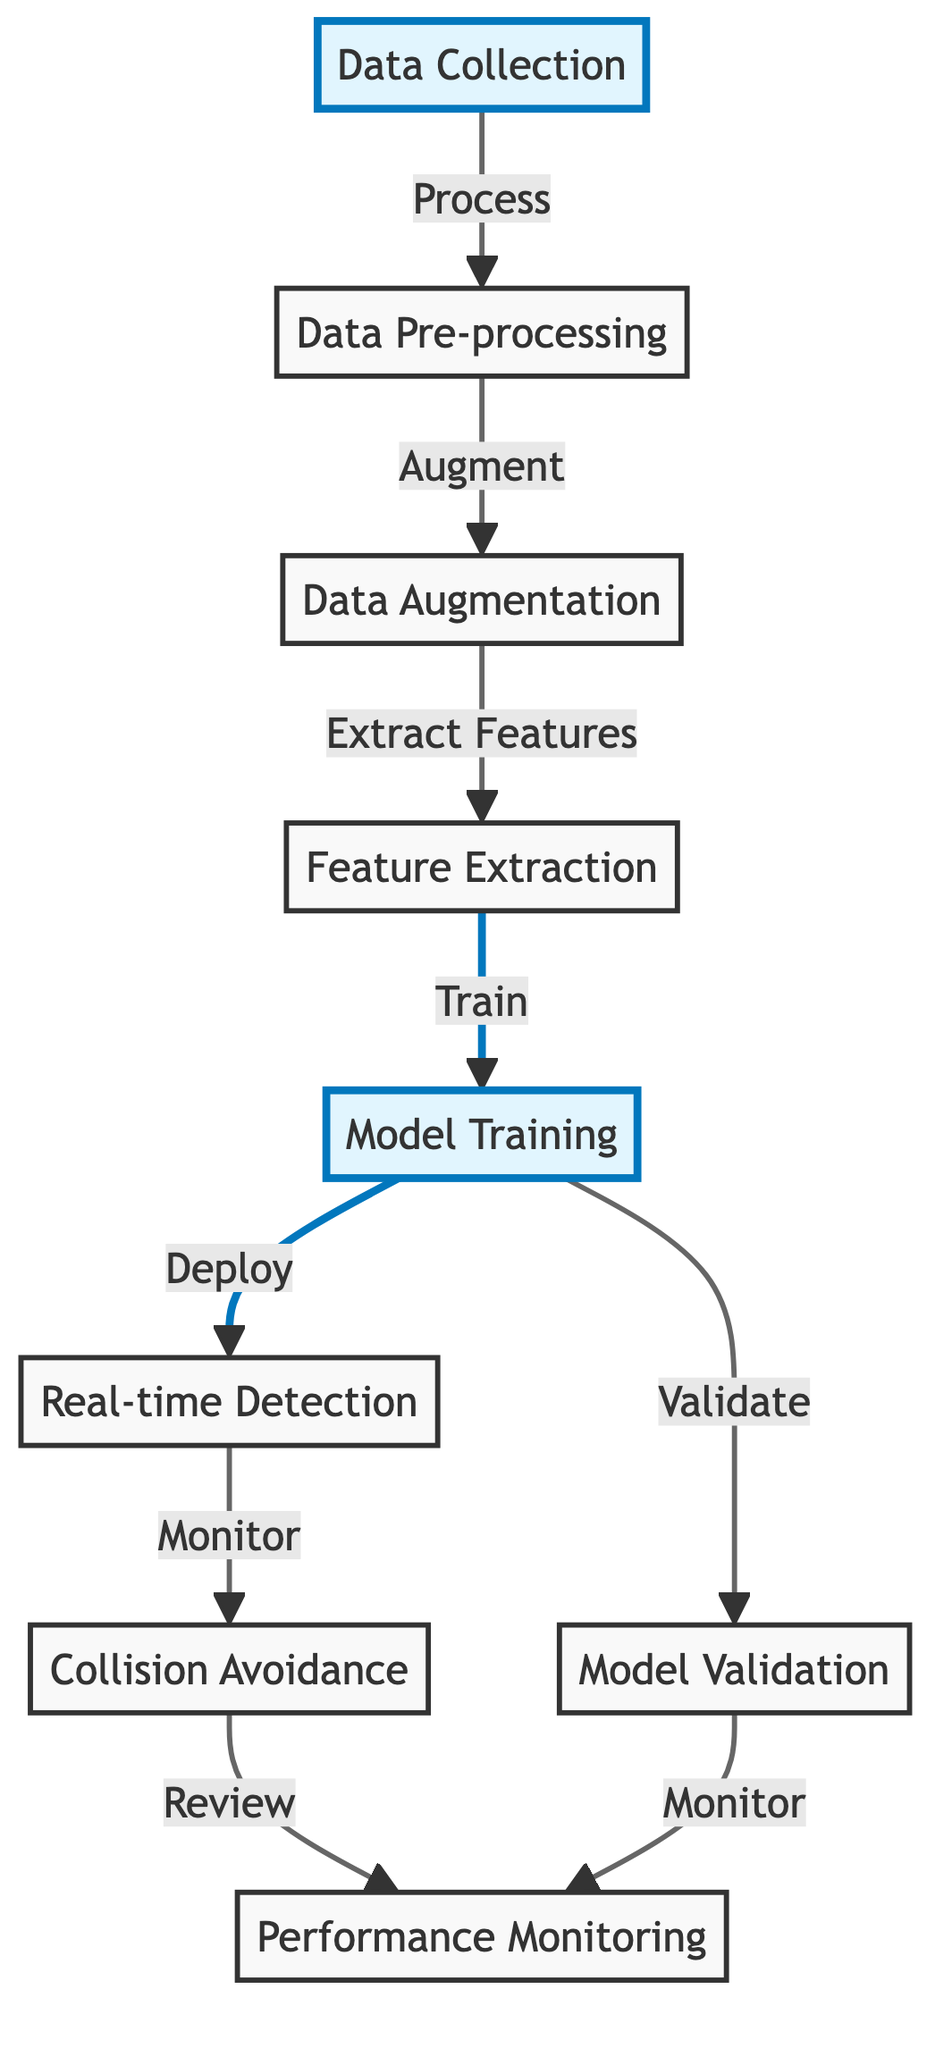What is the first step of the process? The first step in the diagram is labeled as "Data Collection," which is the starting point of the entire process for tracking space debris.
Answer: Data Collection How many main steps are in the diagram? By counting the nodes, there are a total of seven main steps represented: Data Collection, Data Pre-processing, Data Augmentation, Feature Extraction, Model Training, Real-time Detection, and Collision Avoidance.
Answer: Seven Which step directly follows Model Training? According to the diagram, the step that directly follows Model Training is "Real-time Detection," indicating the next action taken after training the model.
Answer: Real-time Detection What is the output of the Model Training step? The output from the Model Training step, as indicated, is "Deploy," which means the trained model is implemented for real-time detection tasks.
Answer: Deploy How does Data Augmentation relate to Feature Extraction? Data Augmentation is directly connected to Feature Extraction, as it enhances the data before the features are extracted for model training. This relationship shows the order in which these processes occur.
Answer: Augment What monitoring steps are indicated in the diagram? The diagram shows two monitoring steps: "Monitor" after Real-time Detection and "Monitor" after Model Validation, which highlight the ongoing assessment of the system's performance in both detection and validation phases.
Answer: Monitor Which steps are highlighted in the diagram? The highlighted steps in the diagram are "Data Collection" and "Model Training," indicating their importance within the process of real-time space debris tracking.
Answer: Data Collection, Model Training What follows Collision Avoidance in the process? Following Collision Avoidance, there is a step for "Review," which suggests that there is an evaluation phase after avoidance measures have been implemented to assess effectiveness.
Answer: Review 